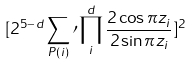Convert formula to latex. <formula><loc_0><loc_0><loc_500><loc_500>[ 2 ^ { 5 - d } \sum _ { P ( i ) } \prime \prod _ { i } ^ { d } \frac { 2 \cos \pi z _ { i } } { 2 \sin \pi z _ { i } } ] ^ { 2 }</formula> 